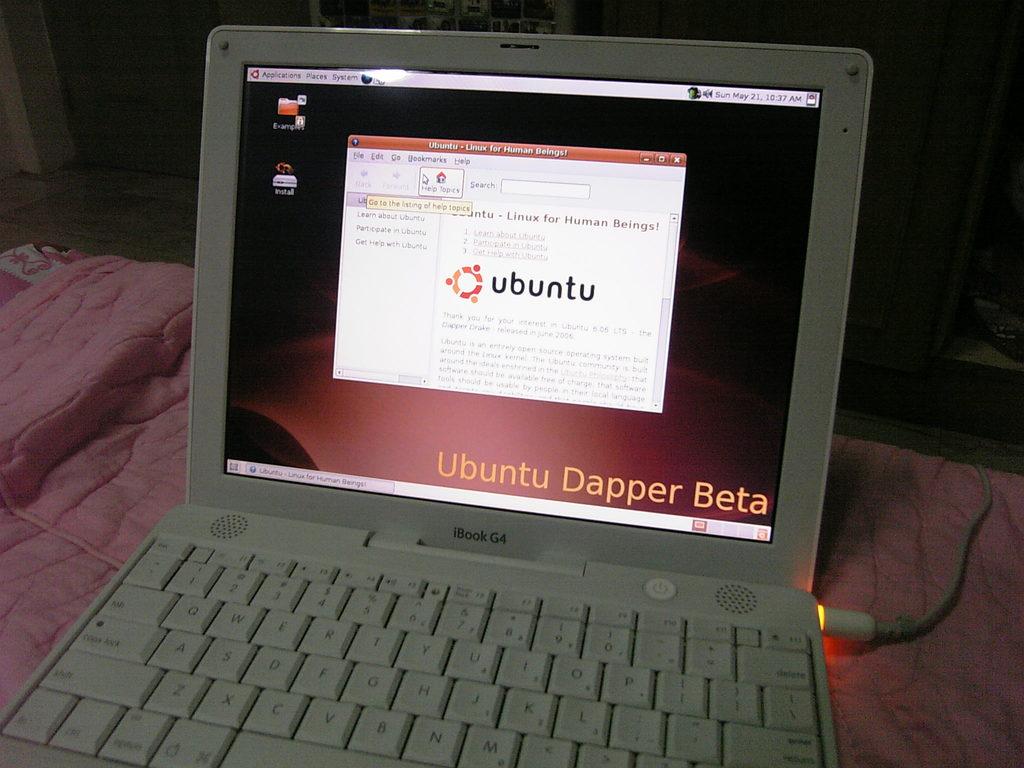What program is up on the screen?
Give a very brief answer. Ubuntu. What opperating system is on this  laptop?
Keep it short and to the point. Ubuntu. 